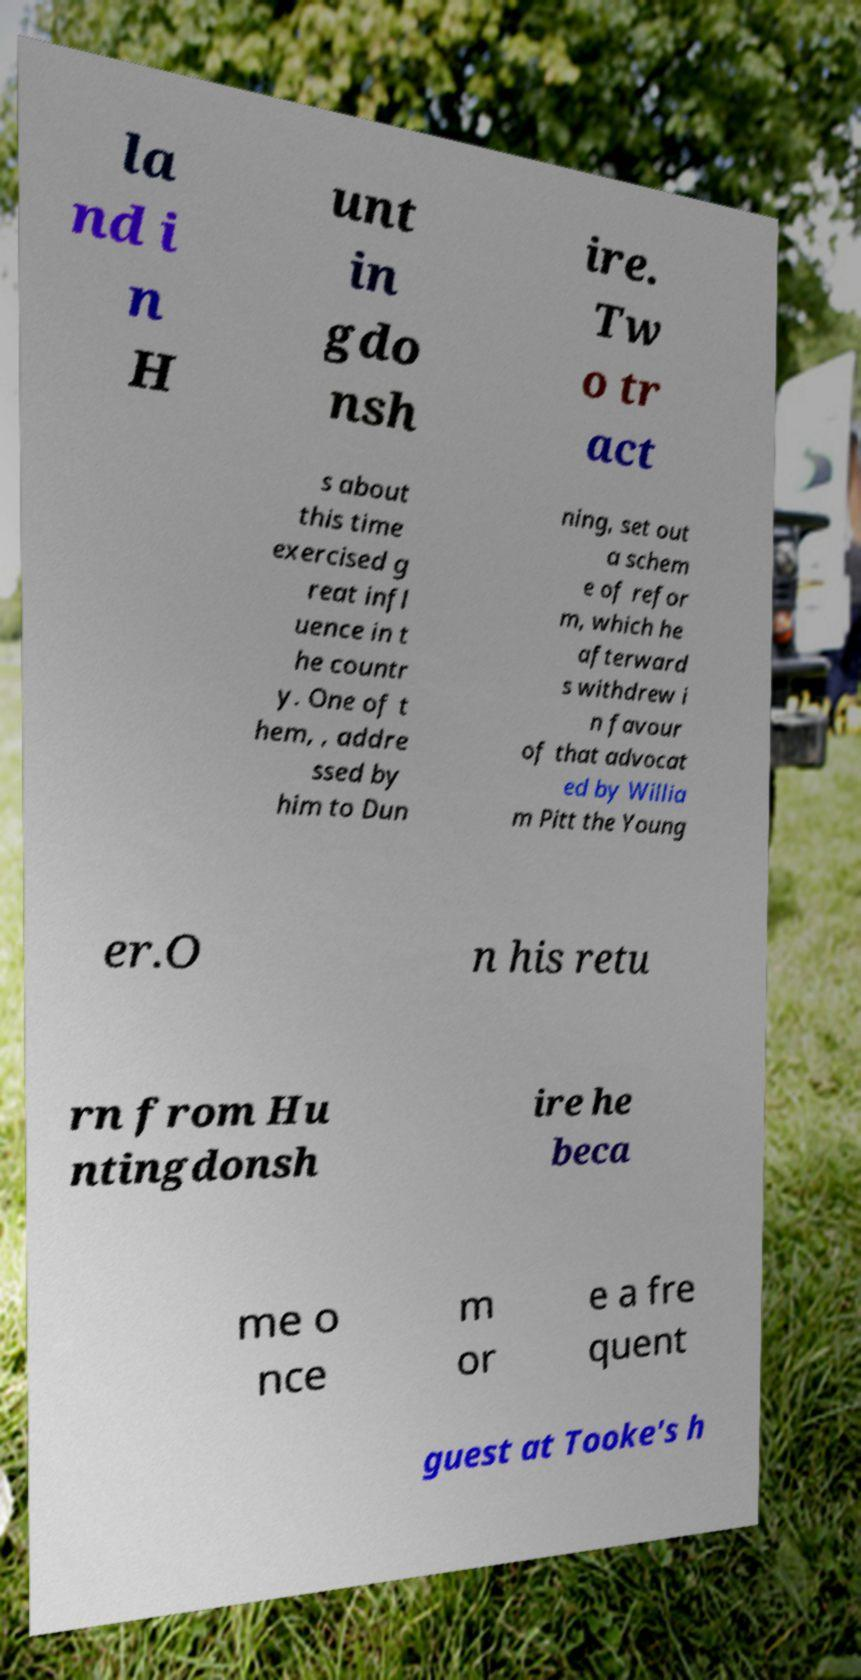Could you extract and type out the text from this image? la nd i n H unt in gdo nsh ire. Tw o tr act s about this time exercised g reat infl uence in t he countr y. One of t hem, , addre ssed by him to Dun ning, set out a schem e of refor m, which he afterward s withdrew i n favour of that advocat ed by Willia m Pitt the Young er.O n his retu rn from Hu ntingdonsh ire he beca me o nce m or e a fre quent guest at Tooke's h 